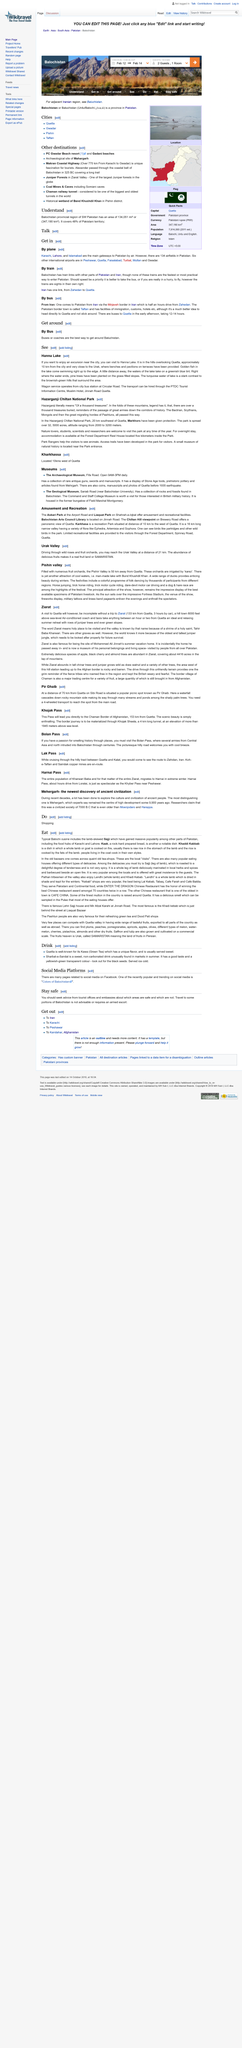Highlight a few significant elements in this photo. Circular Road operates a bus station that provides wagon service. This bus station is the only one in the area that offers this type of service. Hanna Lake is located 10 kilometers from the city, making it a convenient destination for those seeking a peaceful retreat within close proximity to urban areas. Hanna Lake is located near a city that has an Information Centre on Jinnah Road. 